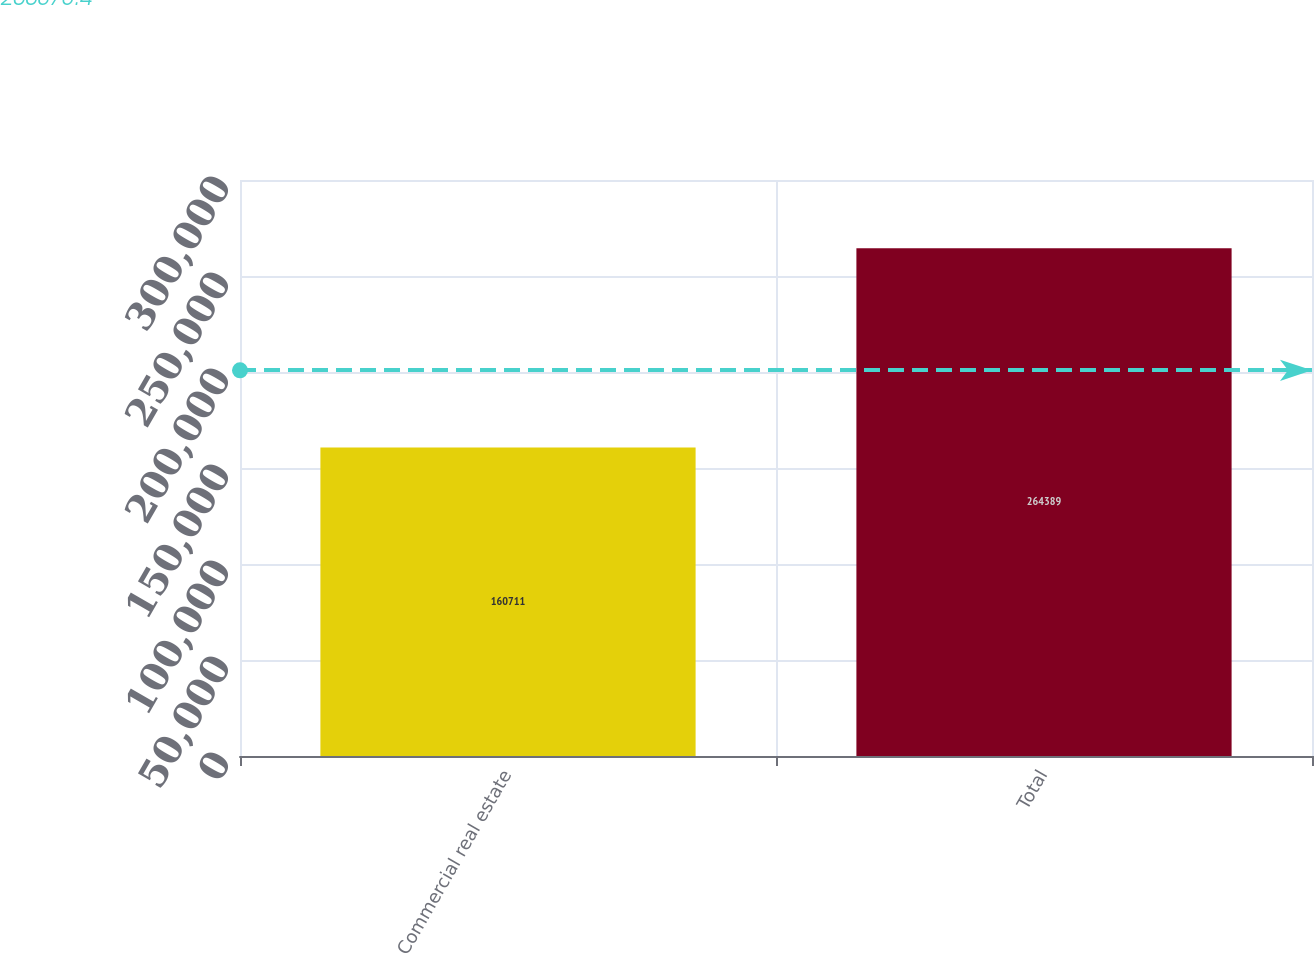Convert chart to OTSL. <chart><loc_0><loc_0><loc_500><loc_500><bar_chart><fcel>Commercial real estate<fcel>Total<nl><fcel>160711<fcel>264389<nl></chart> 